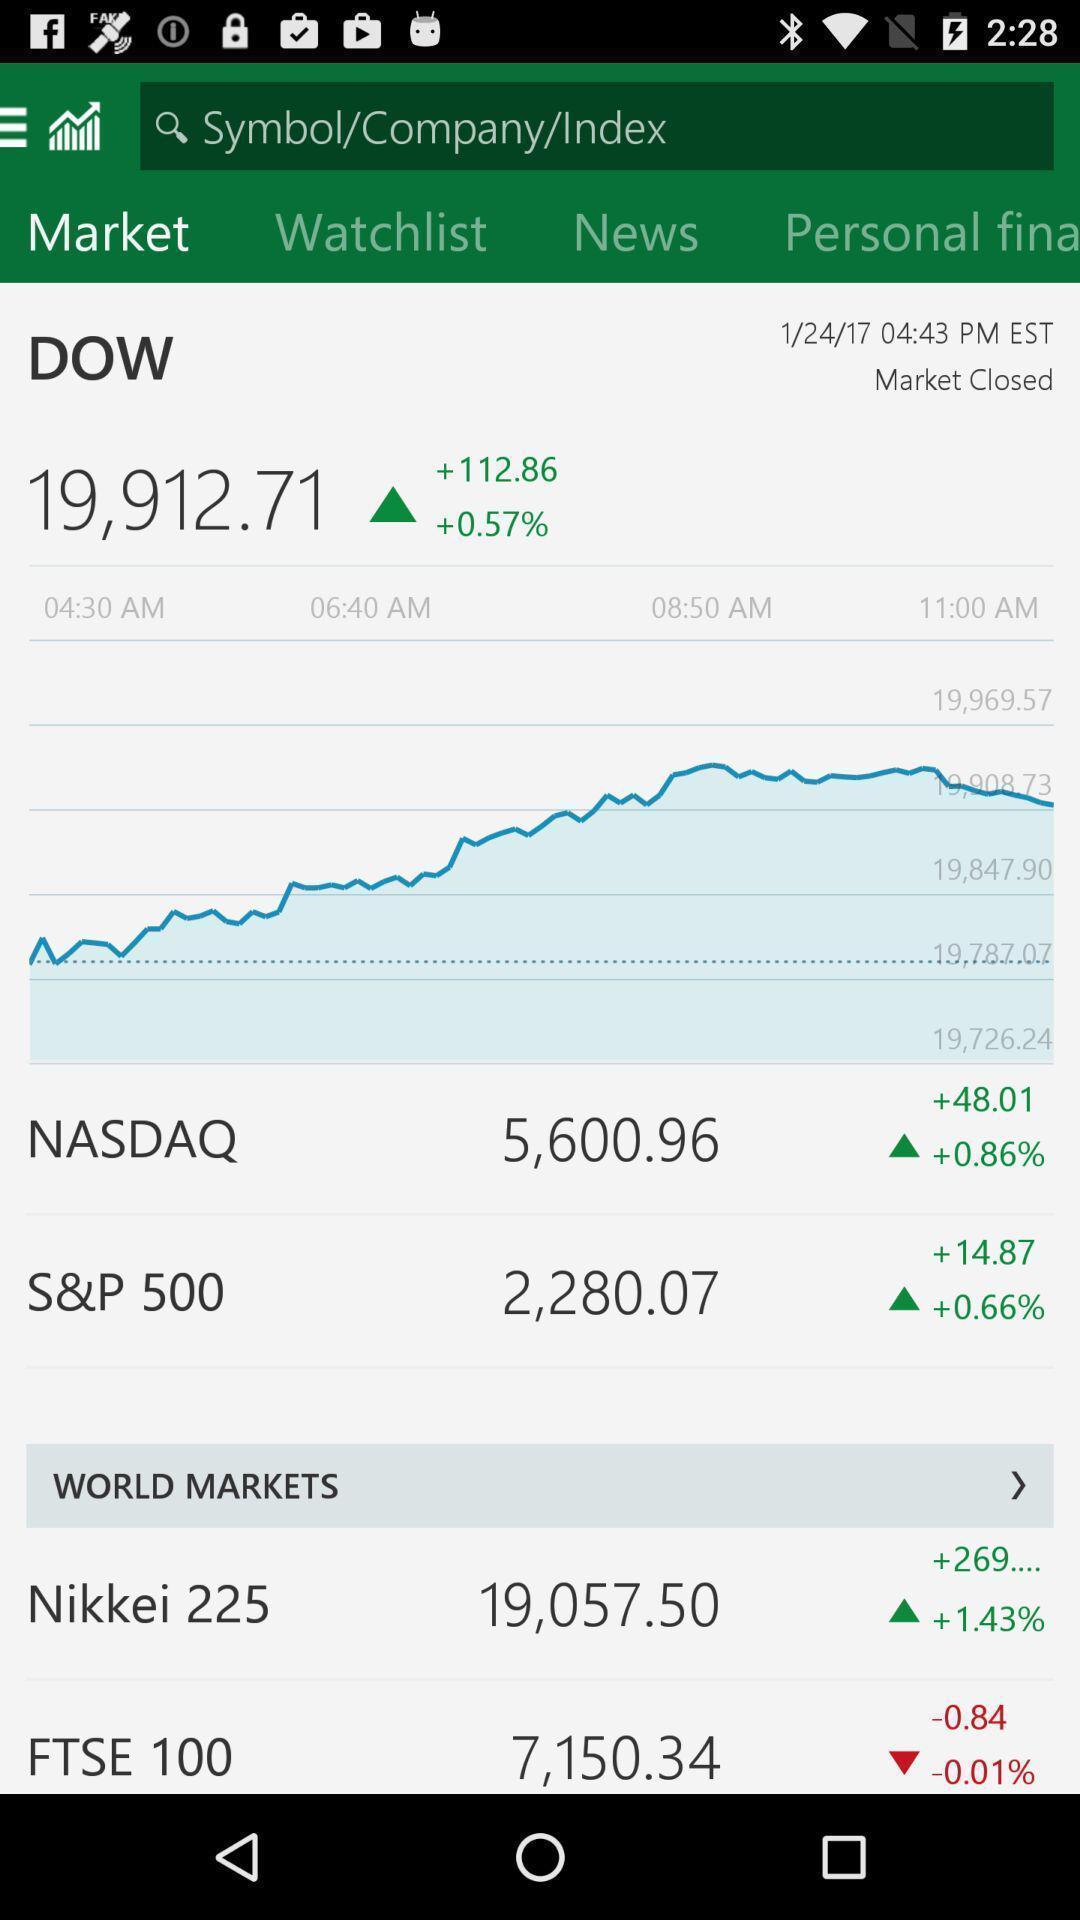Please provide a description for this image. Page displaying with stock market details. 